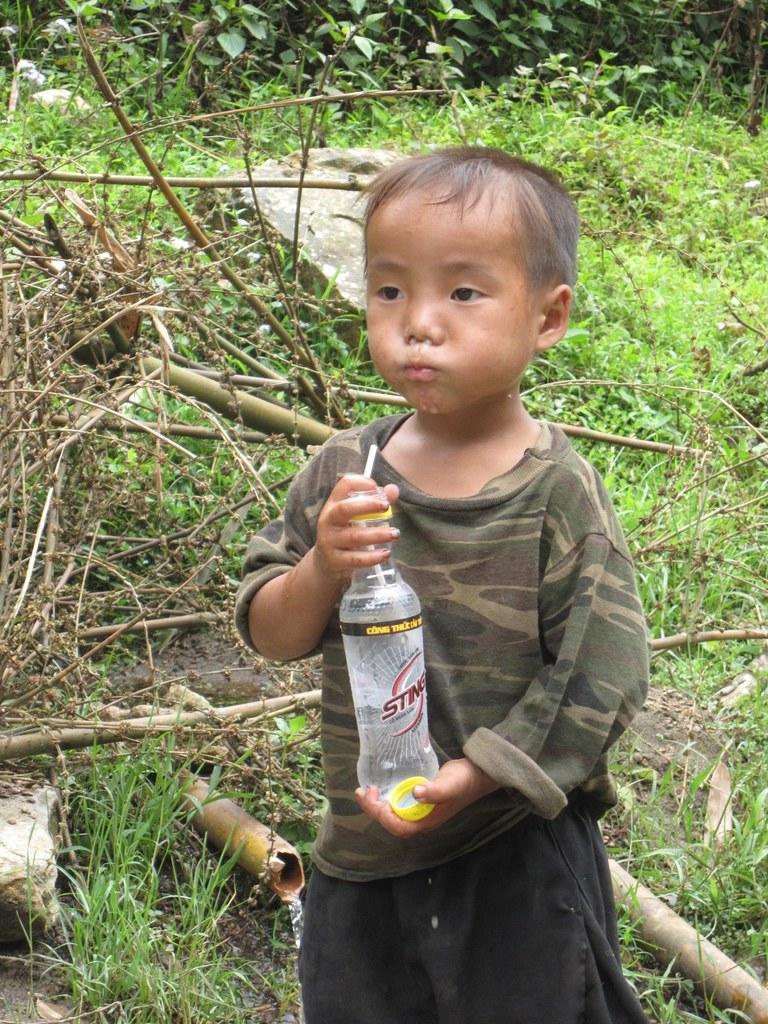Can you describe this image briefly? In this picture, there is a kid holding a bottle in his hand. he is drinking some water. In the background there are some plants and trees here. 